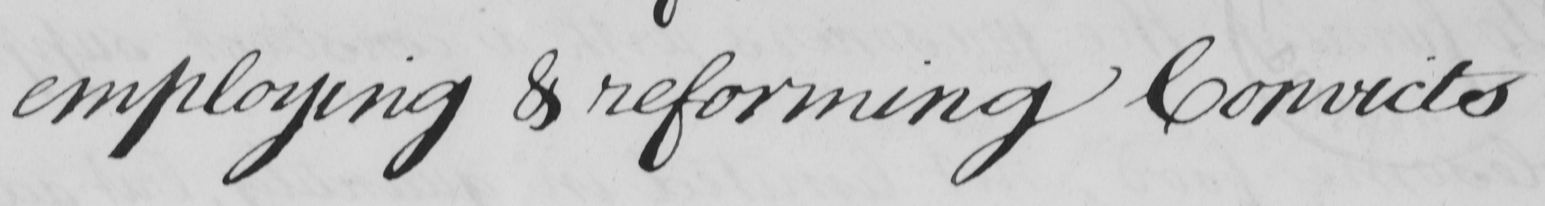What text is written in this handwritten line? employing & reforming Convicts 